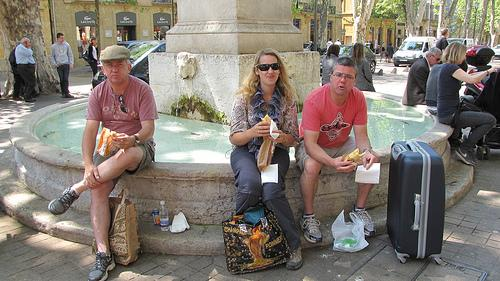What are some of the people in the image doing? Several people are eating sandwiches, while a young woman rests on a statue base and an overweight man talks on his cell phone. Provide a brief overview of the entire scene depicted in the image. Three people enjoy lunch outside, while a young man with luggage stands nearby, a woman rests on a statue base, and various objects like bags, water bottles, and suitcases are scattered around the area. Write a sentence about the relation between people and their surroundings in the image. The image captures a casual scene where people are either eating together, using their phones, or resting with their belongings, surrounded by fountains and tree-lined streets. 